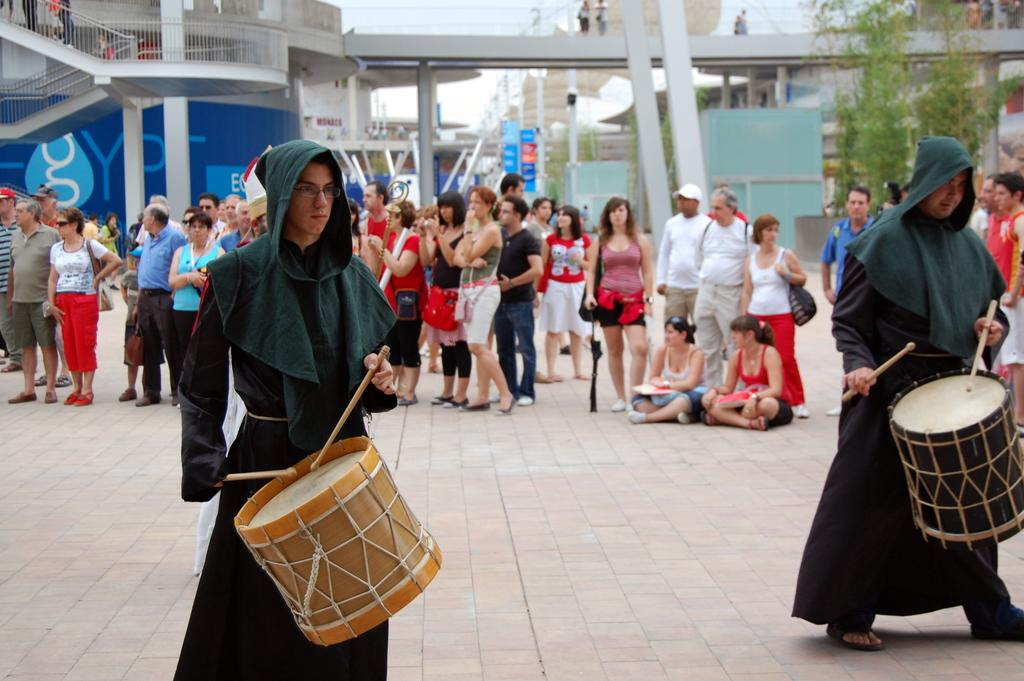How many people are in the image? There is a group of people in the image. What are some of the people in the image doing? Some people are standing, while others are sitting on the floor in the image. What activity are two of the people engaged in? Two guys are playing a musical instrument in the image. What do the two guys playing the musical instrument have in common? The two guys are wearing the same dress. What is the educational level of the people in the image? The facts provided do not give any information about the educational level of the people in the image. --- Facts: 1. There is a car in the image. 2. The car is parked on the street. 3. The car has a flat tire. 4. There is a person standing next to the car. 5. The person is holding a cell phone. Absurd Topics: dance, ocean, bird Conversation: What is the main subject of the image? The main subject of the image is a car. Where is the car located in the image? The car is parked on the street in the image. What is the condition of the car in the image? The car has a flat tire in the image. What is the person standing next to the car doing? The person is holding a cell phone in the image. Reasoning: Let's think step by step in order to produce the conversation. We start by identifying the main subject of the image, which is the car. Then, we describe the location of the car, noting that it is parked on the street. Next, we mention the condition of the car, which has a flat tire. Finally, we focus on the person standing next to the car, mentioning that they are holding a cell phone. Absurd Question/Answer: Can you see any birds flying over the ocean in the image? There is no ocean or birds visible in the image; it features a car with a flat tire and a person holding a cell phone. 